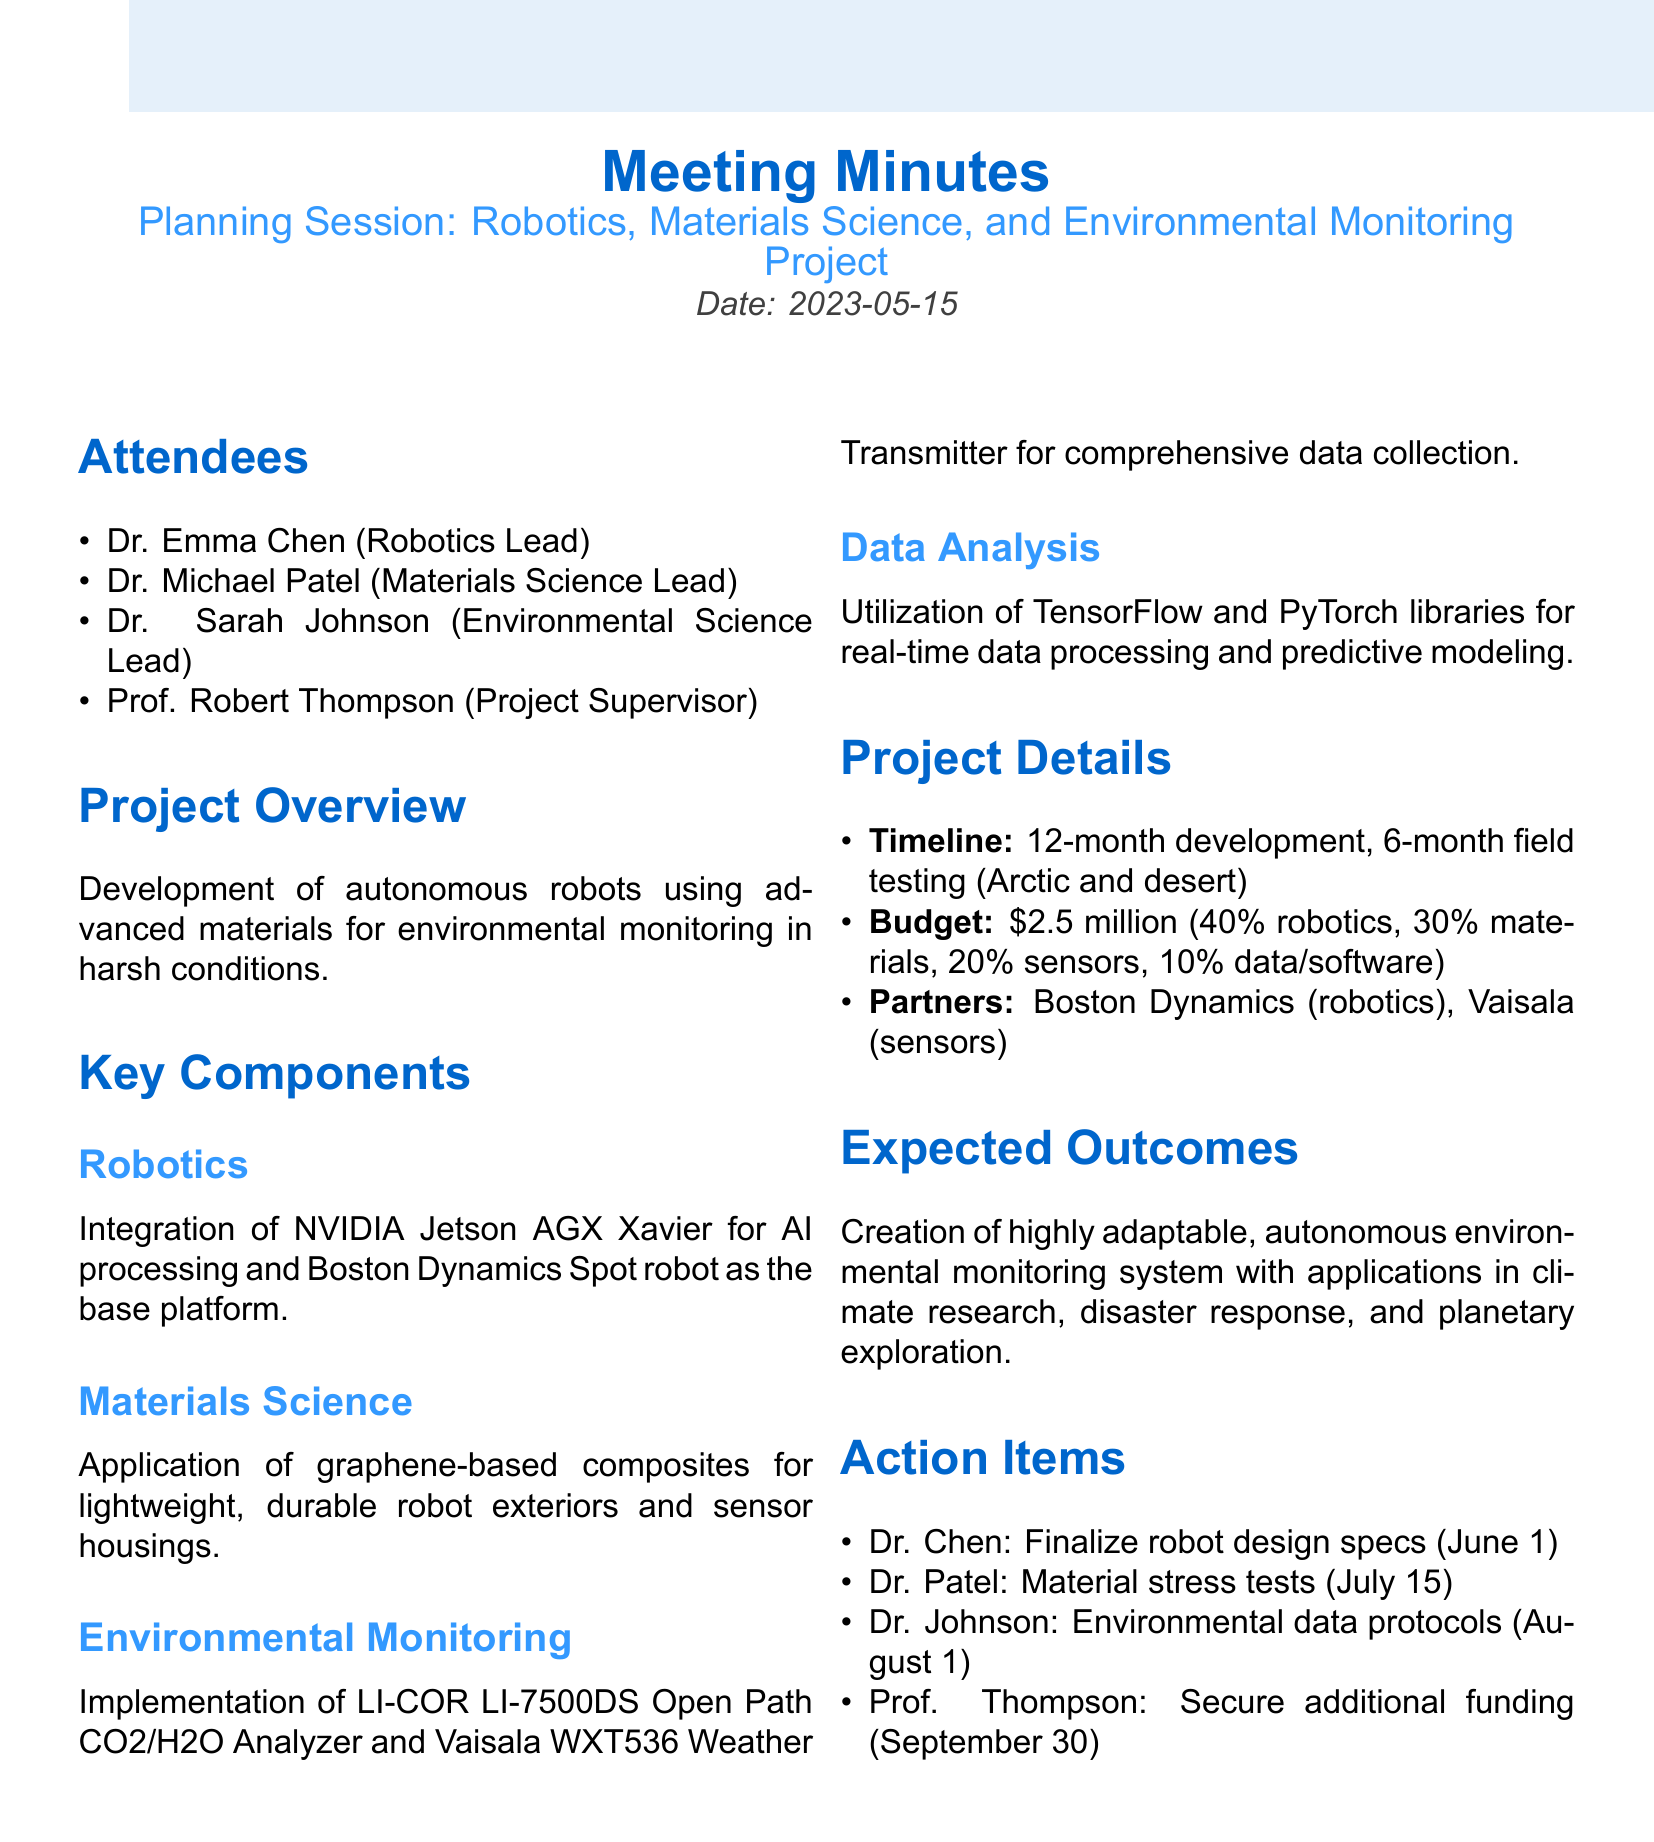What is the date of the meeting? The date of the meeting is provided at the top of the document, which is 2023-05-15.
Answer: 2023-05-15 Who is the Robotics Lead? The Robotics Lead is mentioned in the list of attendees in the document, identified as Dr. Emma Chen.
Answer: Dr. Emma Chen What is the total budget for the project? The total budget is explicitly stated in the budget allocation section, which is $2.5 million.
Answer: $2.5 million What is the expected outcome of the project? The expected outcome is described towards the end of the document and mentions a highly adaptable, autonomous environmental monitoring system.
Answer: Highly adaptable, autonomous environmental monitoring system What is the timeline for the field testing period? The timeline section specifies a 6-month field testing period following the development phase.
Answer: 6-month What is Dr. Patel responsible for by July 15? The action items list specifies that Dr. Patel is to conduct material stress tests under simulated extreme conditions.
Answer: Material stress tests Which robot is used as the base platform? The document lists Boston Dynamics Spot robot as the base platform in the robotics component.
Answer: Boston Dynamics Spot What percentage of the budget is allocated for data analysis and software development? The budget allocation mentions 10% is designated for data analysis and software development.
Answer: 10% 